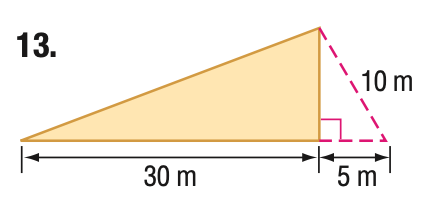Question: Find the area of the triangle. Round to the nearest tenth if necessary.
Choices:
A. 75
B. 106.1
C. 129.9
D. 150
Answer with the letter. Answer: C 